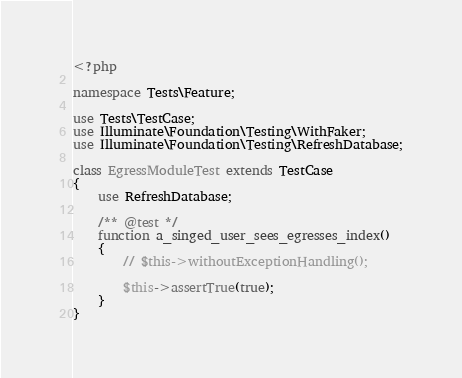<code> <loc_0><loc_0><loc_500><loc_500><_PHP_><?php

namespace Tests\Feature;

use Tests\TestCase;
use Illuminate\Foundation\Testing\WithFaker;
use Illuminate\Foundation\Testing\RefreshDatabase;

class EgressModuleTest extends TestCase
{
	use RefreshDatabase;

    /** @test */
    function a_singed_user_sees_egresses_index()
    {
        // $this->withoutExceptionHandling();

        $this->assertTrue(true);
    }
}
</code> 